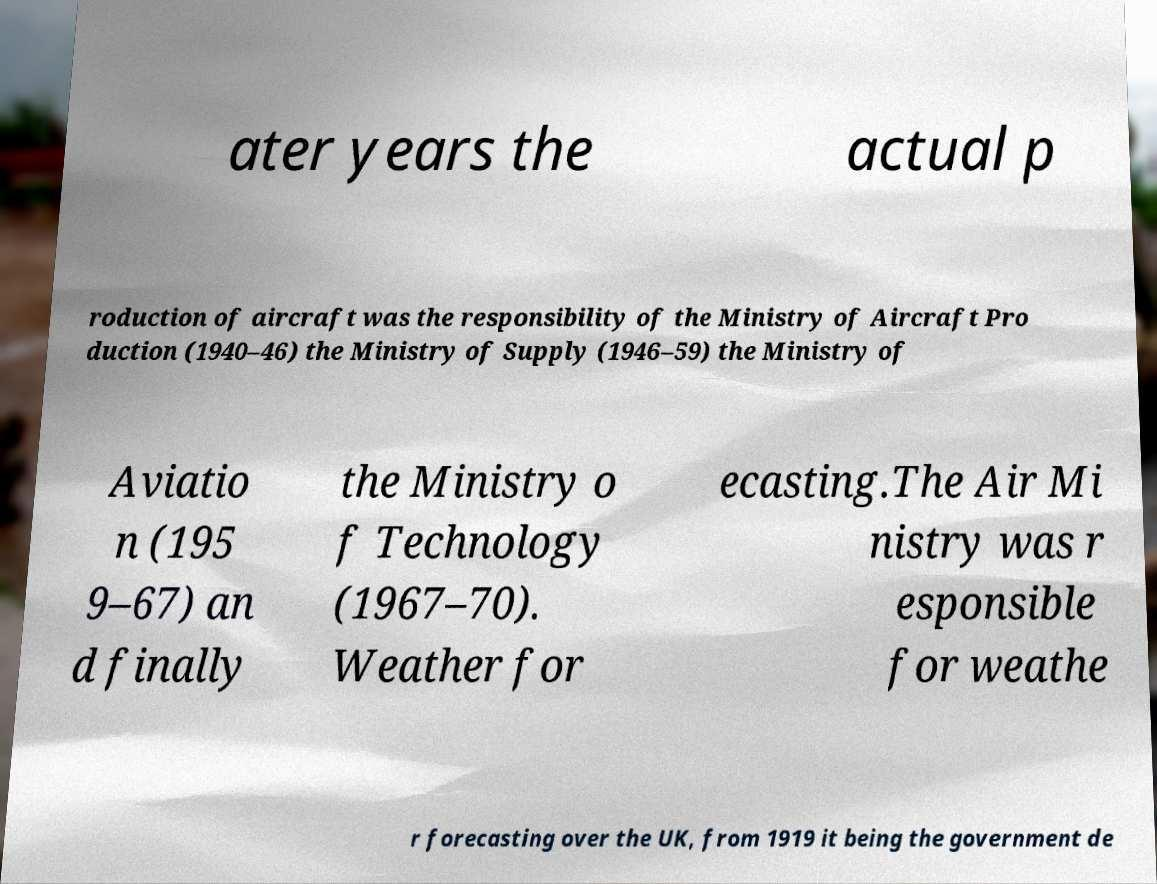Could you assist in decoding the text presented in this image and type it out clearly? ater years the actual p roduction of aircraft was the responsibility of the Ministry of Aircraft Pro duction (1940–46) the Ministry of Supply (1946–59) the Ministry of Aviatio n (195 9–67) an d finally the Ministry o f Technology (1967–70). Weather for ecasting.The Air Mi nistry was r esponsible for weathe r forecasting over the UK, from 1919 it being the government de 